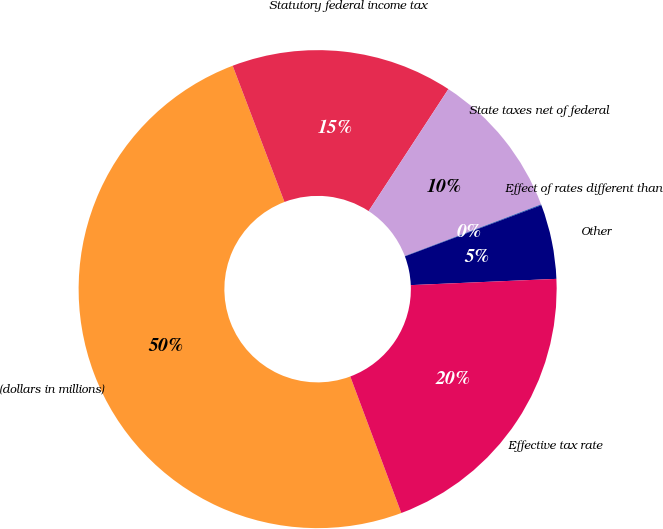Convert chart to OTSL. <chart><loc_0><loc_0><loc_500><loc_500><pie_chart><fcel>(dollars in millions)<fcel>Statutory federal income tax<fcel>State taxes net of federal<fcel>Effect of rates different than<fcel>Other<fcel>Effective tax rate<nl><fcel>49.91%<fcel>15.0%<fcel>10.02%<fcel>0.05%<fcel>5.03%<fcel>19.99%<nl></chart> 